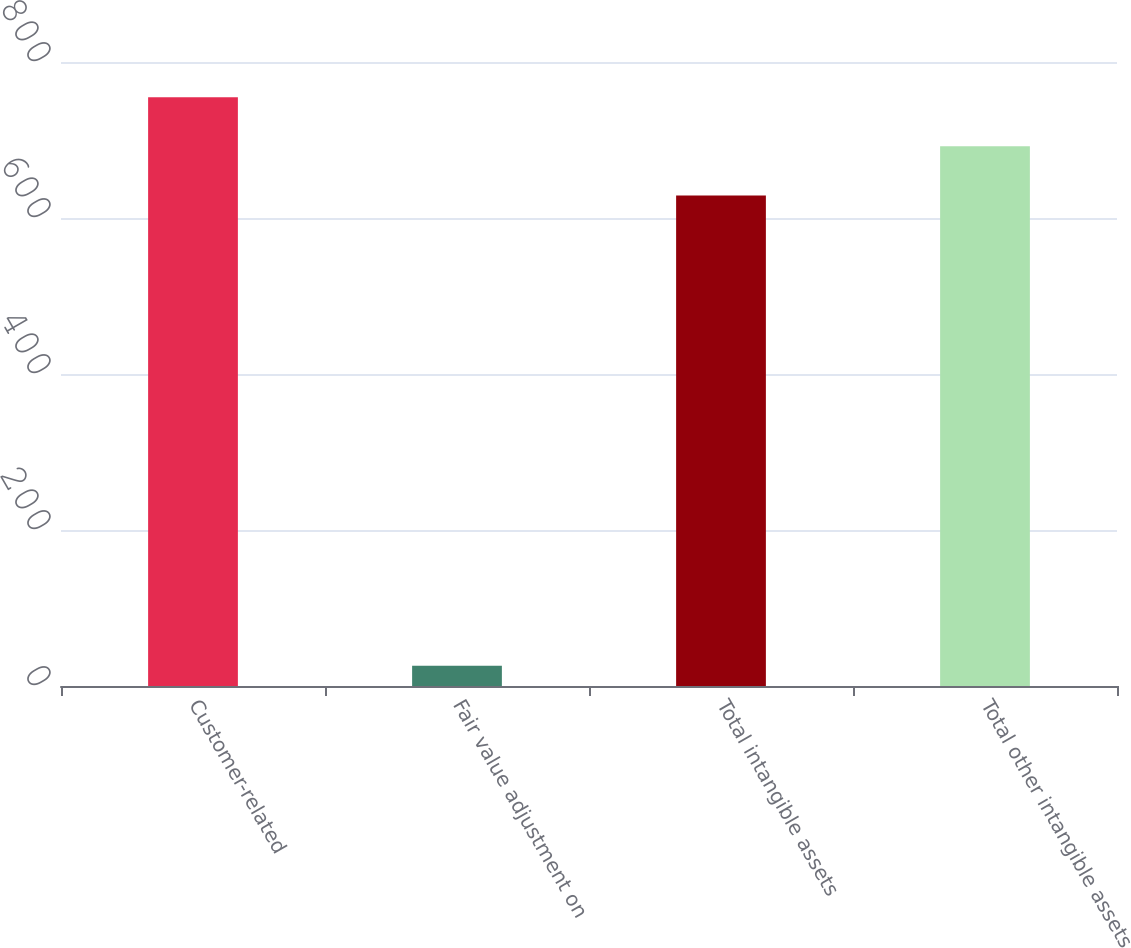<chart> <loc_0><loc_0><loc_500><loc_500><bar_chart><fcel>Customer-related<fcel>Fair value adjustment on<fcel>Total intangible assets<fcel>Total other intangible assets<nl><fcel>754.8<fcel>26<fcel>629<fcel>691.9<nl></chart> 